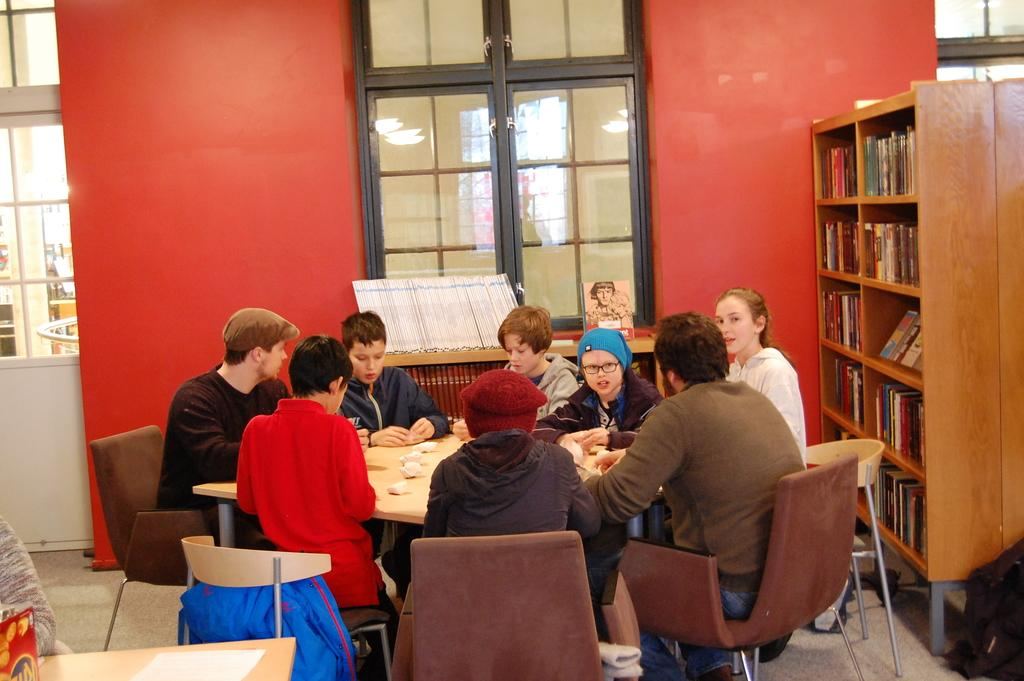What is the main subject of the image? The main subject of the image is a group of children. Where are the children located in the image? The children are sitting in front of a table. What can be seen on the right side of the children? There is a bookshelf on their right. What is visible behind the children? There is a window visible behind the children. What type of spade is being used by the children in the image? There is no spade present in the image; the children are sitting in front of a table. What order are the children sitting in the image? The provided facts do not give information about the order in which the children are sitting. 